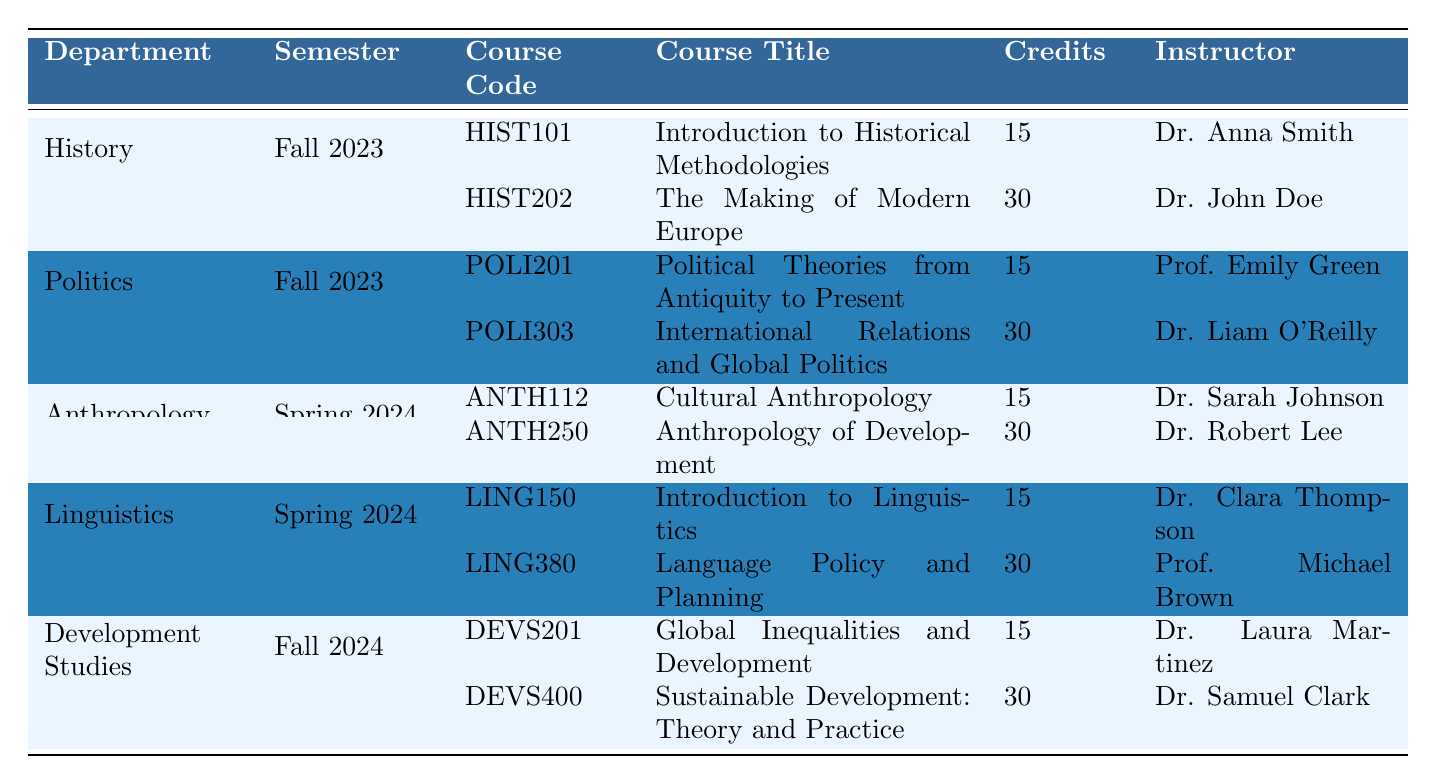What courses are offered by the Politics department in Fall 2023? According to the table, the Politics department offers two courses in Fall 2023: POLI201 and POLI303.
Answer: POLI201 and POLI303 How many credits is the course "Language Policy and Planning"? The table shows that the course "Language Policy and Planning" (LING380) has 30 credits.
Answer: 30 credits What is the total number of credits for all courses offered in History for Fall 2023? The courses offered in History for Fall 2023 are HIST101 (15 credits) and HIST202 (30 credits). Summing them gives 15 + 30 = 45 credits.
Answer: 45 credits Is "Cultural Anthropology" offered in Spring 2024? The table indicates that "Cultural Anthropology" (ANTH112) is indeed listed under Anthropology for Spring 2024.
Answer: Yes Which department has the highest single course credit offering in Fall 2023? In Fall 2023, History offers a course with 30 credits (HIST202), and Politics also has a course with 30 credits (POLI303). Therefore, the highest offering is 30 credits, shared by History and Politics.
Answer: History and Politics If a student takes all courses offered in Spring 2024, how many total credits will they earn? In Spring 2024, Anthropology offers ANTH112 (15 credits) and ANTH250 (30 credits), while Linguistics offers LING150 (15 credits) and LING380 (30 credits). The total is 15 + 30 + 15 + 30 = 90 credits.
Answer: 90 credits What is the average number of credits per course offered in the Development Studies department for Fall 2024? Development Studies offers two courses: DEVS201 (15 credits) and DEVS400 (30 credits). To find the average: (15 + 30) / 2 = 22.5 credits.
Answer: 22.5 credits Which instructor teaches the course "Sustainable Development: Theory and Practice"? The table shows that "Sustainable Development: Theory and Practice" (DEVS400) is taught by Dr. Samuel Clark.
Answer: Dr. Samuel Clark How many courses are offered in the Linguistics department during Spring 2024? The Linguistics department has two courses listed for Spring 2024: LING150 and LING380.
Answer: 2 courses Is there any course in Fall 2024 that has less than 30 credits? The courses listed for Fall 2024 in Development Studies are DEVS201 (15 credits) and DEVS400 (30 credits). Since DEVS201 has less than 30 credits, the answer is yes.
Answer: Yes What is the difference in credits between the courses "The Making of Modern Europe" and "Global Inequalities and Development"? "The Making of Modern Europe" (HIST202) has 30 credits, and "Global Inequalities and Development" (DEVS201) has 15 credits. The difference is 30 - 15 = 15 credits.
Answer: 15 credits 